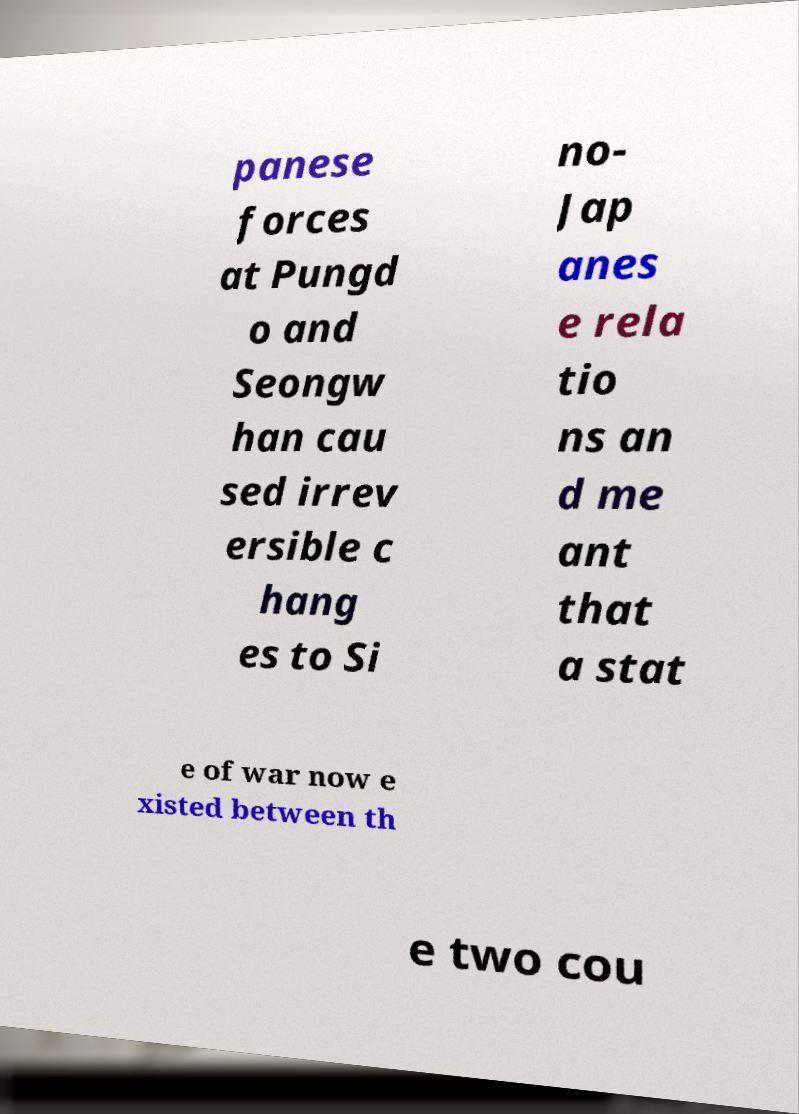I need the written content from this picture converted into text. Can you do that? panese forces at Pungd o and Seongw han cau sed irrev ersible c hang es to Si no- Jap anes e rela tio ns an d me ant that a stat e of war now e xisted between th e two cou 